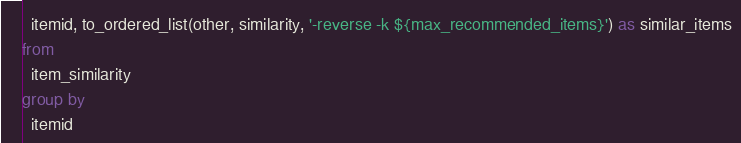<code> <loc_0><loc_0><loc_500><loc_500><_SQL_>  itemid, to_ordered_list(other, similarity, '-reverse -k ${max_recommended_items}') as similar_items
from 
  item_similarity
group by
  itemid</code> 